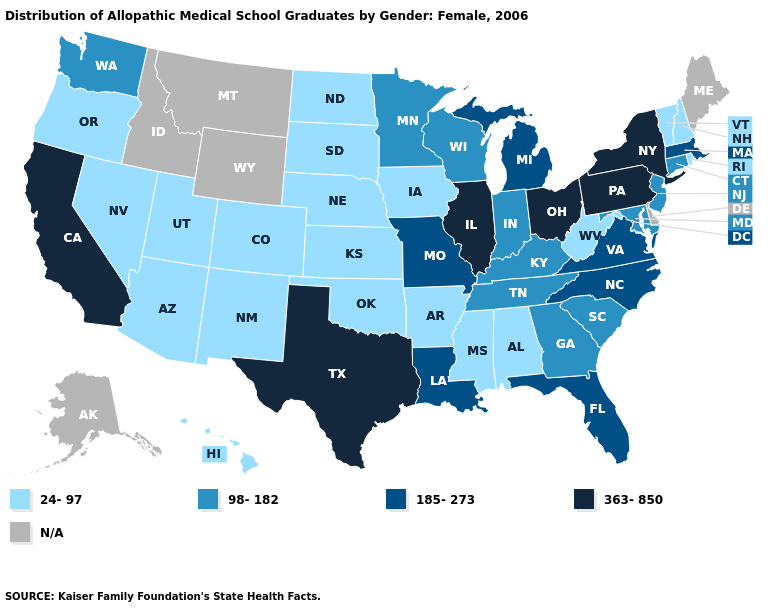Among the states that border Pennsylvania , which have the lowest value?
Be succinct. West Virginia. What is the value of Idaho?
Answer briefly. N/A. What is the highest value in the USA?
Be succinct. 363-850. What is the value of Kentucky?
Answer briefly. 98-182. What is the value of Oklahoma?
Quick response, please. 24-97. What is the lowest value in the USA?
Be succinct. 24-97. Which states have the lowest value in the MidWest?
Be succinct. Iowa, Kansas, Nebraska, North Dakota, South Dakota. How many symbols are there in the legend?
Be succinct. 5. Name the states that have a value in the range 98-182?
Concise answer only. Connecticut, Georgia, Indiana, Kentucky, Maryland, Minnesota, New Jersey, South Carolina, Tennessee, Washington, Wisconsin. Does Massachusetts have the lowest value in the Northeast?
Write a very short answer. No. 